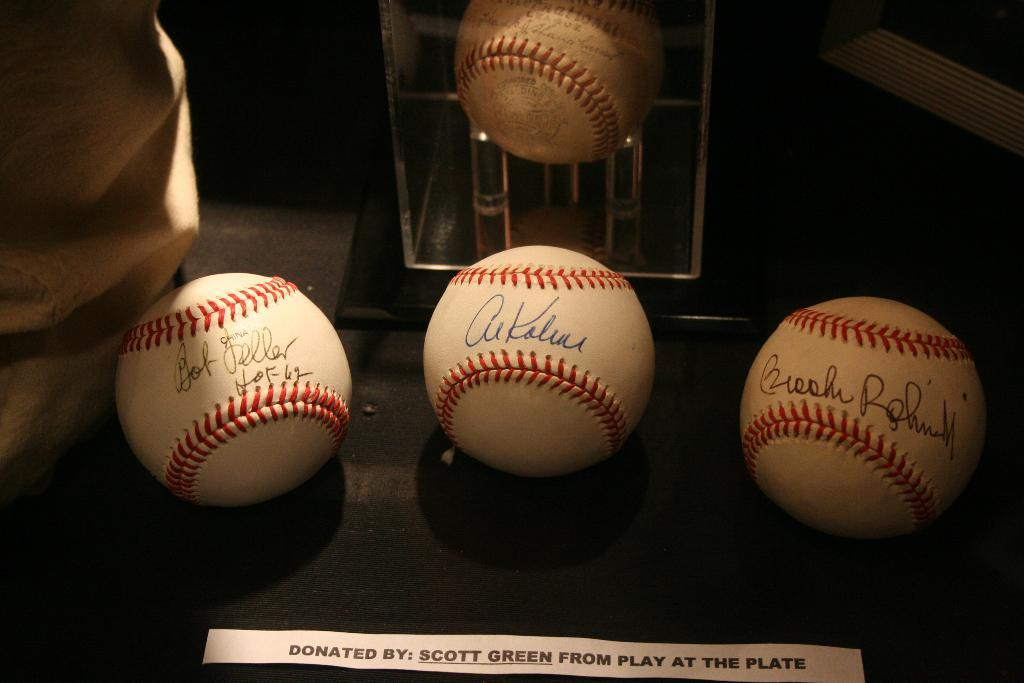<image>
Present a compact description of the photo's key features. 4 signed baseballs are displayed with a note that says Donated By: Scott Green From Play At The Plate. 